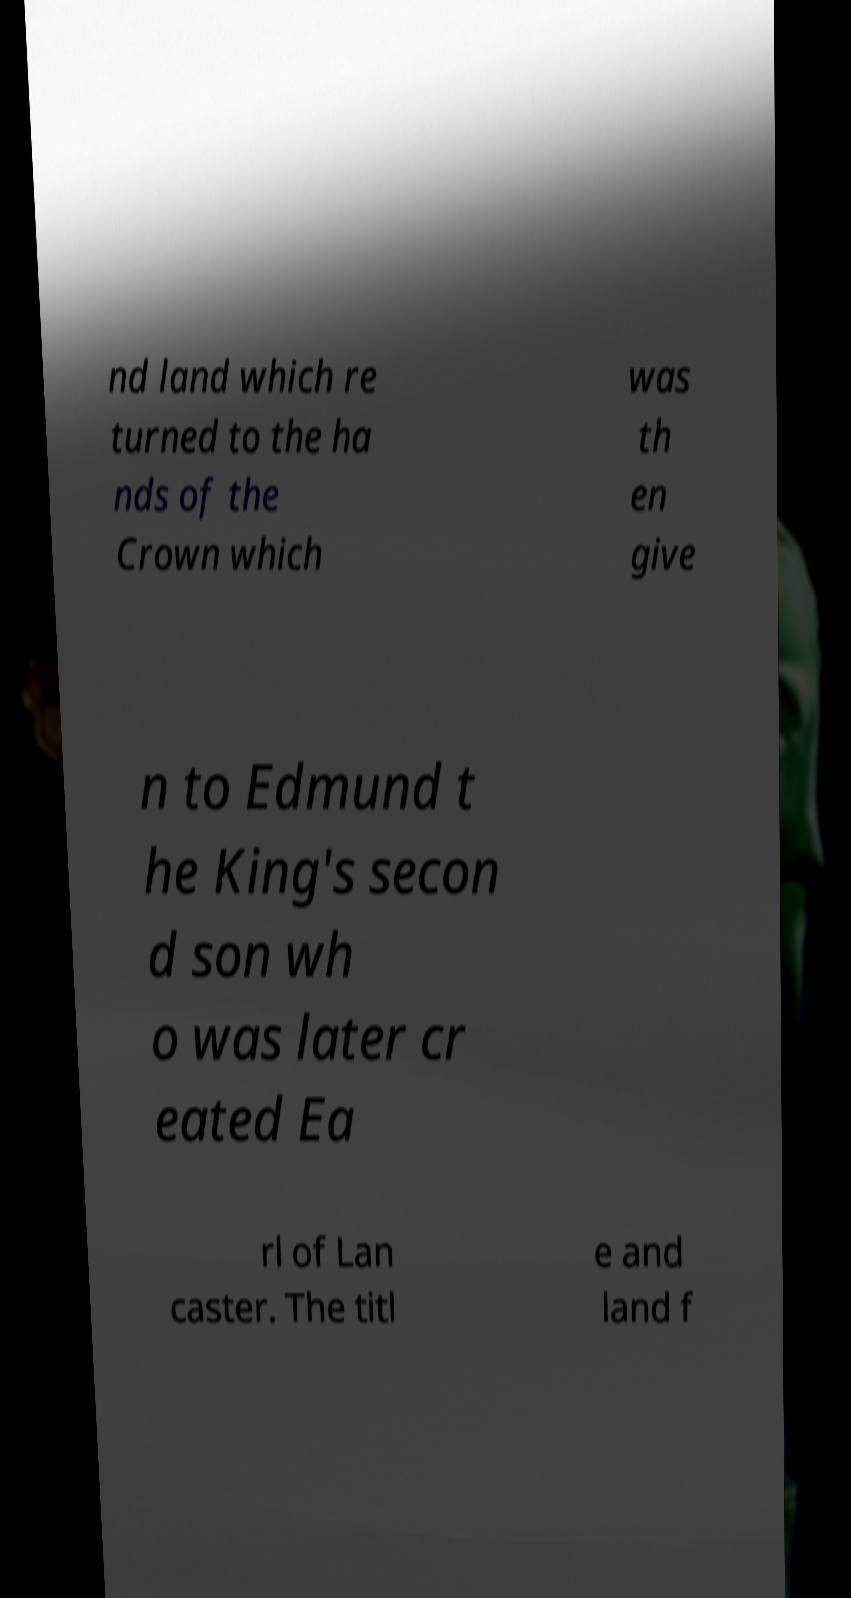Please identify and transcribe the text found in this image. nd land which re turned to the ha nds of the Crown which was th en give n to Edmund t he King's secon d son wh o was later cr eated Ea rl of Lan caster. The titl e and land f 